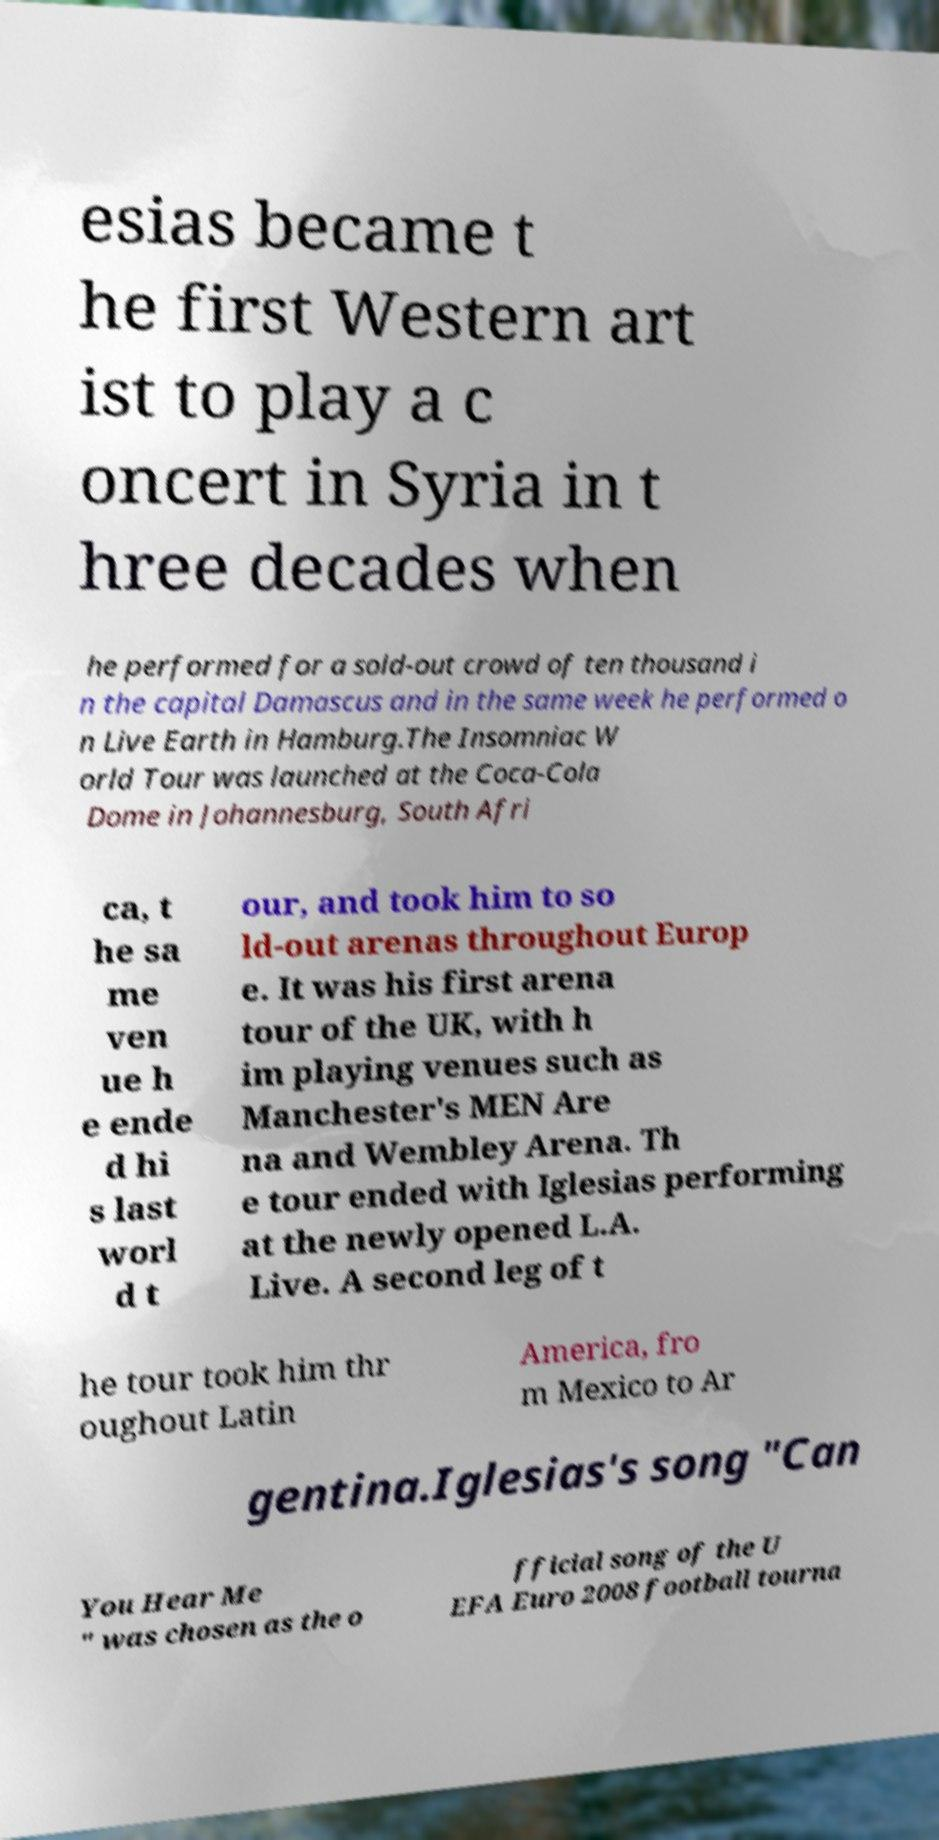Could you assist in decoding the text presented in this image and type it out clearly? esias became t he first Western art ist to play a c oncert in Syria in t hree decades when he performed for a sold-out crowd of ten thousand i n the capital Damascus and in the same week he performed o n Live Earth in Hamburg.The Insomniac W orld Tour was launched at the Coca-Cola Dome in Johannesburg, South Afri ca, t he sa me ven ue h e ende d hi s last worl d t our, and took him to so ld-out arenas throughout Europ e. It was his first arena tour of the UK, with h im playing venues such as Manchester's MEN Are na and Wembley Arena. Th e tour ended with Iglesias performing at the newly opened L.A. Live. A second leg of t he tour took him thr oughout Latin America, fro m Mexico to Ar gentina.Iglesias's song "Can You Hear Me " was chosen as the o fficial song of the U EFA Euro 2008 football tourna 